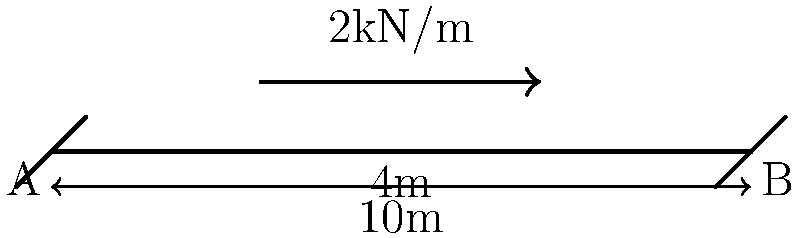A simply supported beam in a low-income housing structure spans 10 meters and carries a uniformly distributed load of 2 kN/m over the middle 4 meters. Calculate the maximum bending moment in the beam. To find the maximum bending moment, we'll follow these steps:

1) First, calculate the total load:
   $P = 2 \text{ kN/m} \times 4 \text{ m} = 8 \text{ kN}$

2) Find the reactions at the supports:
   Due to symmetry, $R_A = R_B = \frac{P}{2} = 4 \text{ kN}$

3) The maximum bending moment will occur at the center of the beam. To calculate it, we can consider half of the beam:

   $M_{max} = R_A \times 5\text{ m} - \frac{P}{2} \times (5\text{ m} - 2\text{ m})$

4) Substitute the values:
   $M_{max} = 4 \text{ kN} \times 5\text{ m} - 4 \text{ kN} \times 3\text{ m}$
   $M_{max} = 20 \text{ kN}\cdot\text{m} - 12 \text{ kN}\cdot\text{m}$

5) Calculate the final result:
   $M_{max} = 8 \text{ kN}\cdot\text{m}$

This maximum bending moment is crucial for assessing the structural integrity of the beam in low-income housing, as it determines the required strength of the beam to prevent failure.
Answer: 8 kN·m 